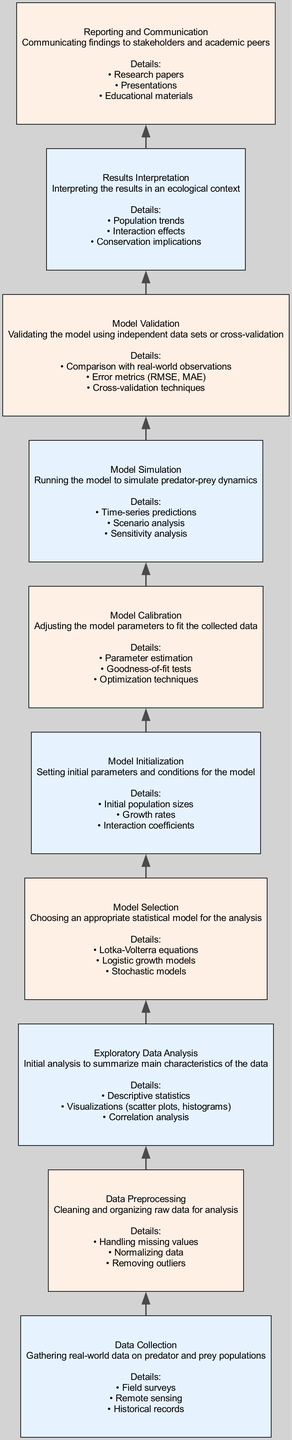What is the first step in the flow chart? The first step in the flow chart is "Data Collection," which involves gathering real-world data on predator and prey populations. This is the starting point indicated at the bottom of the flow diagram, representing the foundation for further processes.
Answer: Data Collection How many elements are there in the flow chart? The flow chart consists of ten elements, each representing a key step in the statistical modeling of predator-prey dynamics. By counting each distinct node in the chart, we find that there are exactly ten.
Answer: 10 Which node comes after "Model Initialization"? The node that comes after "Model Initialization" is "Model Calibration." This transition is established by following the directional flow of the chart upwards, indicating the sequential process after setting the model's initial parameters.
Answer: Model Calibration What type of models is chosen in the "Model Selection" step? In the "Model Selection" step, the chosen models include the "Lotka-Volterra equations," "Logistic growth models," and "Stochastic models." These specific options are directly listed in the node for model selection.
Answer: Lotka-Volterra equations, Logistic growth models, Stochastic models What is the primary purpose of the "Model Validation" step? The primary purpose of the "Model Validation" step is to validate the model using independent data sets or cross-validation. This step is crucial to ensure that the simulated dynamics accurately reflect real-world scenarios by comparing model predictions with actual observations.
Answer: Validate the model using independent data sets or cross-validation Which step involves interpreting population trends? The step that involves interpreting population trends is "Results Interpretation." This step synthesizes the findings from the model simulation and places them within an ecological context to assess the impact on predator and prey populations.
Answer: Results Interpretation What is performed during "Data Preprocessing"? During "Data Preprocessing," activities like handling missing values, normalizing data, and removing outliers are performed. This description provides a clear picture of the data cleaning activities essential before analysis begins.
Answer: Handling missing values, normalizing data, removing outliers What follows "Model Simulation" in the flow chart? Following "Model Simulation" in the flow chart is "Model Validation." This clearly indicated progression shows that the simulation outcomes need to be validated to assess the reliability of the model predictions.
Answer: Model Validation How does "Exploratory Data Analysis" contribute to subsequent steps? "Exploratory Data Analysis" contributes to subsequent steps by summarizing the main characteristics of the data through descriptive statistics, visualizations, and correlation analysis. This exploration lays the groundwork for informed decisions in model selection and calibration.
Answer: Summarizing main characteristics of the data through descriptive statistics, visualizations, and correlation analysis 